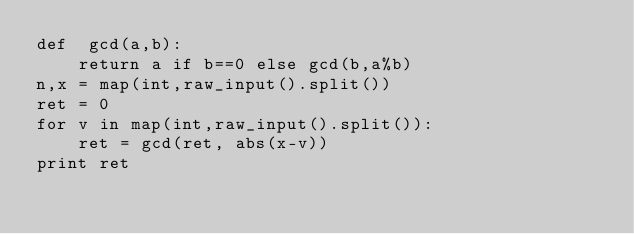<code> <loc_0><loc_0><loc_500><loc_500><_Python_>def  gcd(a,b):
    return a if b==0 else gcd(b,a%b)
n,x = map(int,raw_input().split())
ret = 0
for v in map(int,raw_input().split()):
    ret = gcd(ret, abs(x-v))
print ret</code> 